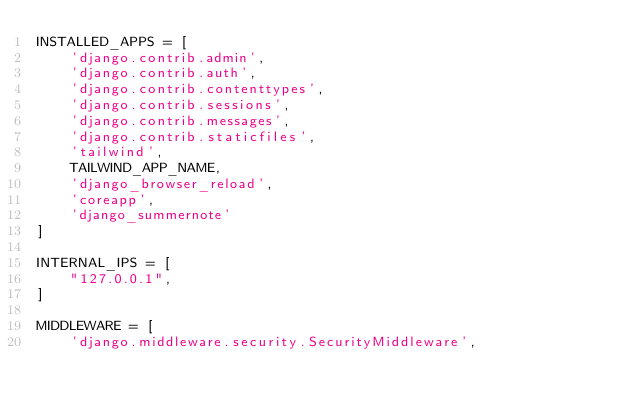Convert code to text. <code><loc_0><loc_0><loc_500><loc_500><_Python_>INSTALLED_APPS = [
    'django.contrib.admin',
    'django.contrib.auth',
    'django.contrib.contenttypes',
    'django.contrib.sessions',
    'django.contrib.messages',
    'django.contrib.staticfiles',
    'tailwind',
    TAILWIND_APP_NAME,
    'django_browser_reload',
    'coreapp',
    'django_summernote'
]

INTERNAL_IPS = [
    "127.0.0.1",
]

MIDDLEWARE = [
    'django.middleware.security.SecurityMiddleware',</code> 